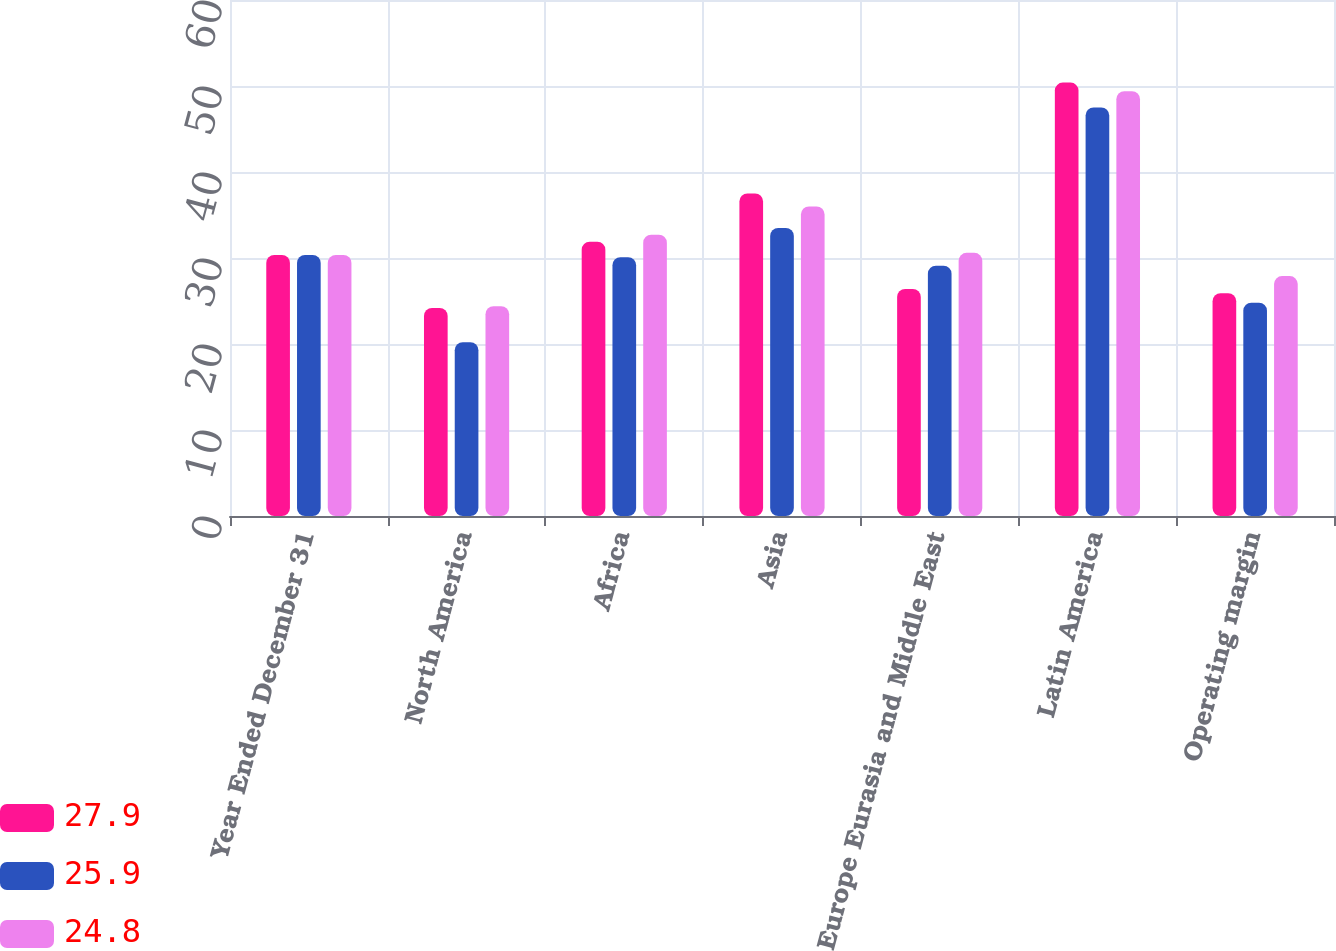Convert chart to OTSL. <chart><loc_0><loc_0><loc_500><loc_500><stacked_bar_chart><ecel><fcel>Year Ended December 31<fcel>North America<fcel>Africa<fcel>Asia<fcel>Europe Eurasia and Middle East<fcel>Latin America<fcel>Operating margin<nl><fcel>27.9<fcel>30.35<fcel>24.2<fcel>31.9<fcel>37.5<fcel>26.4<fcel>50.4<fcel>25.9<nl><fcel>25.9<fcel>30.35<fcel>20.2<fcel>30.1<fcel>33.5<fcel>29.1<fcel>47.5<fcel>24.8<nl><fcel>24.8<fcel>30.35<fcel>24.4<fcel>32.7<fcel>36<fcel>30.6<fcel>49.4<fcel>27.9<nl></chart> 